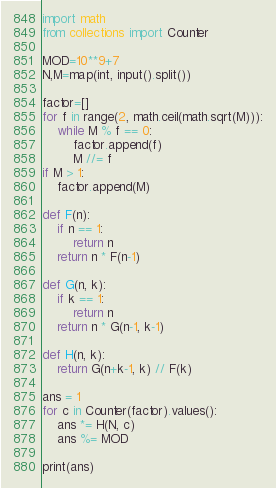<code> <loc_0><loc_0><loc_500><loc_500><_Python_>import math
from collections import Counter

MOD=10**9+7
N,M=map(int, input().split())

factor=[]
for f in range(2, math.ceil(math.sqrt(M))):
	while M % f == 0:
		factor.append(f)
		M //= f
if M > 1:
	factor.append(M)

def F(n):
	if n == 1:
		return n
	return n * F(n-1)

def G(n, k):
	if k == 1:
		return n
	return n * G(n-1, k-1)

def H(n, k):
	return G(n+k-1, k) // F(k)

ans = 1
for c in Counter(factor).values():
	ans *= H(N, c)
	ans %= MOD

print(ans)
</code> 